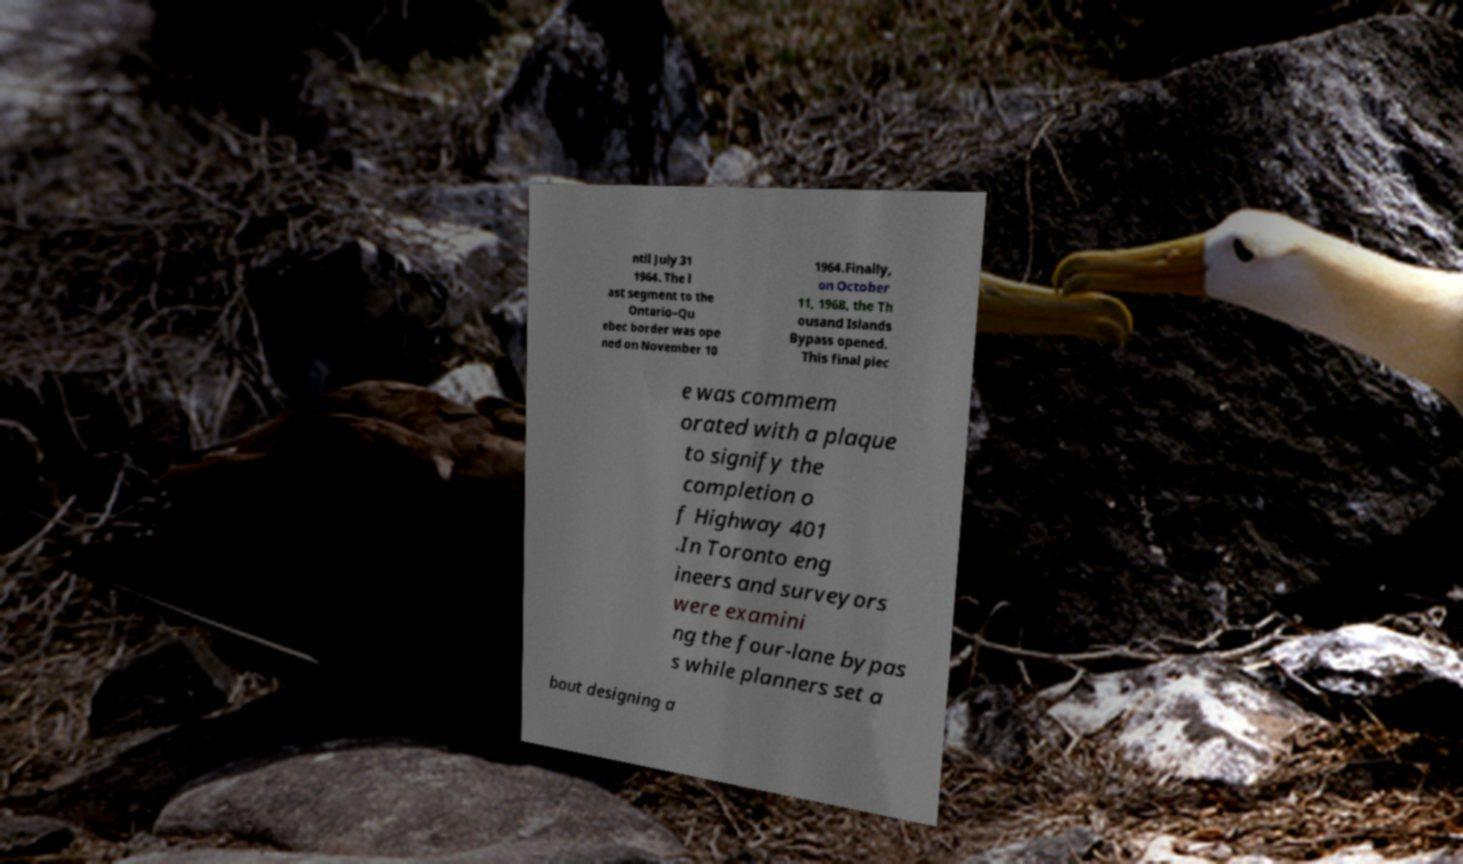Could you extract and type out the text from this image? ntil July 31 1964. The l ast segment to the Ontario–Qu ebec border was ope ned on November 10 1964.Finally, on October 11, 1968, the Th ousand Islands Bypass opened. This final piec e was commem orated with a plaque to signify the completion o f Highway 401 .In Toronto eng ineers and surveyors were examini ng the four-lane bypas s while planners set a bout designing a 